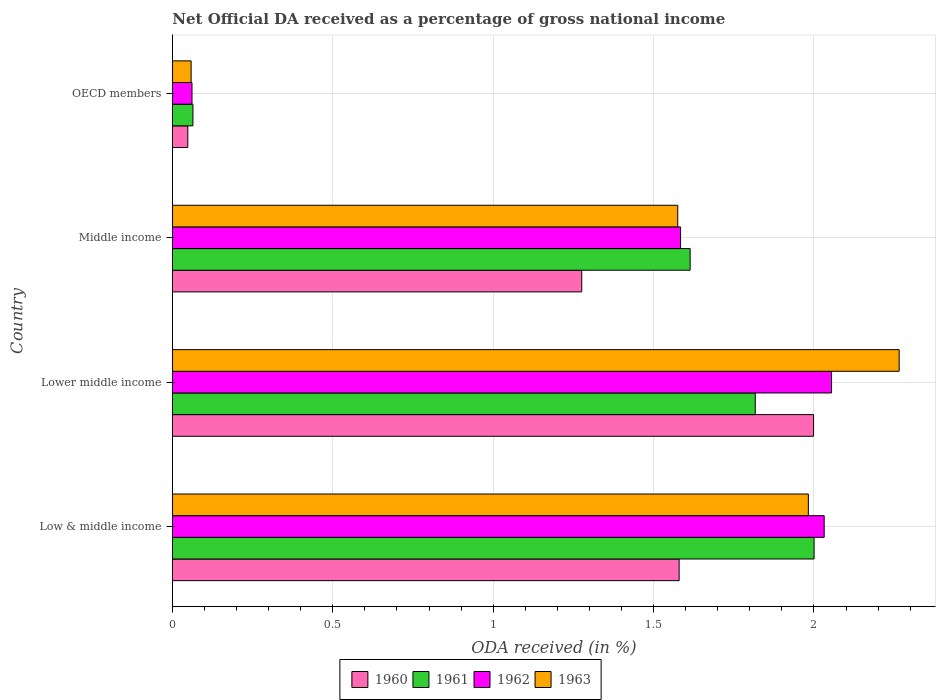How many different coloured bars are there?
Your answer should be very brief. 4. Are the number of bars per tick equal to the number of legend labels?
Provide a succinct answer. Yes. Are the number of bars on each tick of the Y-axis equal?
Offer a very short reply. Yes. How many bars are there on the 2nd tick from the bottom?
Your response must be concise. 4. What is the label of the 1st group of bars from the top?
Give a very brief answer. OECD members. In how many cases, is the number of bars for a given country not equal to the number of legend labels?
Ensure brevity in your answer.  0. What is the net official DA received in 1960 in Middle income?
Provide a succinct answer. 1.28. Across all countries, what is the maximum net official DA received in 1961?
Your answer should be compact. 2. Across all countries, what is the minimum net official DA received in 1961?
Offer a very short reply. 0.06. In which country was the net official DA received in 1961 maximum?
Provide a succinct answer. Low & middle income. What is the total net official DA received in 1960 in the graph?
Make the answer very short. 4.9. What is the difference between the net official DA received in 1962 in Low & middle income and that in Lower middle income?
Provide a short and direct response. -0.02. What is the difference between the net official DA received in 1963 in Middle income and the net official DA received in 1961 in Low & middle income?
Make the answer very short. -0.42. What is the average net official DA received in 1960 per country?
Your answer should be compact. 1.23. What is the difference between the net official DA received in 1960 and net official DA received in 1961 in Low & middle income?
Provide a succinct answer. -0.42. What is the ratio of the net official DA received in 1962 in Lower middle income to that in OECD members?
Provide a succinct answer. 33.57. What is the difference between the highest and the second highest net official DA received in 1961?
Your answer should be very brief. 0.18. What is the difference between the highest and the lowest net official DA received in 1963?
Ensure brevity in your answer.  2.21. Is it the case that in every country, the sum of the net official DA received in 1960 and net official DA received in 1961 is greater than the sum of net official DA received in 1963 and net official DA received in 1962?
Provide a succinct answer. No. What does the 2nd bar from the top in Lower middle income represents?
Offer a very short reply. 1962. What does the 4th bar from the bottom in Middle income represents?
Provide a short and direct response. 1963. Is it the case that in every country, the sum of the net official DA received in 1960 and net official DA received in 1963 is greater than the net official DA received in 1962?
Offer a terse response. Yes. How many countries are there in the graph?
Keep it short and to the point. 4. Does the graph contain any zero values?
Keep it short and to the point. No. Does the graph contain grids?
Your response must be concise. Yes. How are the legend labels stacked?
Offer a very short reply. Horizontal. What is the title of the graph?
Provide a short and direct response. Net Official DA received as a percentage of gross national income. What is the label or title of the X-axis?
Ensure brevity in your answer.  ODA received (in %). What is the label or title of the Y-axis?
Offer a terse response. Country. What is the ODA received (in %) in 1960 in Low & middle income?
Provide a short and direct response. 1.58. What is the ODA received (in %) in 1961 in Low & middle income?
Offer a terse response. 2. What is the ODA received (in %) of 1962 in Low & middle income?
Ensure brevity in your answer.  2.03. What is the ODA received (in %) in 1963 in Low & middle income?
Make the answer very short. 1.98. What is the ODA received (in %) of 1960 in Lower middle income?
Your answer should be very brief. 2. What is the ODA received (in %) in 1961 in Lower middle income?
Offer a terse response. 1.82. What is the ODA received (in %) in 1962 in Lower middle income?
Ensure brevity in your answer.  2.05. What is the ODA received (in %) in 1963 in Lower middle income?
Make the answer very short. 2.27. What is the ODA received (in %) of 1960 in Middle income?
Provide a short and direct response. 1.28. What is the ODA received (in %) in 1961 in Middle income?
Your answer should be compact. 1.61. What is the ODA received (in %) of 1962 in Middle income?
Offer a very short reply. 1.58. What is the ODA received (in %) of 1963 in Middle income?
Give a very brief answer. 1.58. What is the ODA received (in %) in 1960 in OECD members?
Provide a short and direct response. 0.05. What is the ODA received (in %) in 1961 in OECD members?
Offer a terse response. 0.06. What is the ODA received (in %) of 1962 in OECD members?
Offer a terse response. 0.06. What is the ODA received (in %) of 1963 in OECD members?
Your answer should be very brief. 0.06. Across all countries, what is the maximum ODA received (in %) of 1960?
Ensure brevity in your answer.  2. Across all countries, what is the maximum ODA received (in %) in 1961?
Offer a terse response. 2. Across all countries, what is the maximum ODA received (in %) in 1962?
Your answer should be very brief. 2.05. Across all countries, what is the maximum ODA received (in %) of 1963?
Provide a short and direct response. 2.27. Across all countries, what is the minimum ODA received (in %) in 1960?
Provide a succinct answer. 0.05. Across all countries, what is the minimum ODA received (in %) in 1961?
Offer a very short reply. 0.06. Across all countries, what is the minimum ODA received (in %) in 1962?
Your response must be concise. 0.06. Across all countries, what is the minimum ODA received (in %) of 1963?
Offer a very short reply. 0.06. What is the total ODA received (in %) of 1960 in the graph?
Ensure brevity in your answer.  4.9. What is the total ODA received (in %) of 1961 in the graph?
Your answer should be very brief. 5.5. What is the total ODA received (in %) in 1962 in the graph?
Your answer should be compact. 5.73. What is the total ODA received (in %) in 1963 in the graph?
Offer a terse response. 5.88. What is the difference between the ODA received (in %) of 1960 in Low & middle income and that in Lower middle income?
Provide a succinct answer. -0.42. What is the difference between the ODA received (in %) in 1961 in Low & middle income and that in Lower middle income?
Offer a very short reply. 0.18. What is the difference between the ODA received (in %) in 1962 in Low & middle income and that in Lower middle income?
Give a very brief answer. -0.02. What is the difference between the ODA received (in %) of 1963 in Low & middle income and that in Lower middle income?
Offer a terse response. -0.28. What is the difference between the ODA received (in %) of 1960 in Low & middle income and that in Middle income?
Your response must be concise. 0.3. What is the difference between the ODA received (in %) in 1961 in Low & middle income and that in Middle income?
Keep it short and to the point. 0.39. What is the difference between the ODA received (in %) in 1962 in Low & middle income and that in Middle income?
Provide a short and direct response. 0.45. What is the difference between the ODA received (in %) of 1963 in Low & middle income and that in Middle income?
Provide a succinct answer. 0.41. What is the difference between the ODA received (in %) in 1960 in Low & middle income and that in OECD members?
Your answer should be very brief. 1.53. What is the difference between the ODA received (in %) of 1961 in Low & middle income and that in OECD members?
Offer a terse response. 1.94. What is the difference between the ODA received (in %) of 1962 in Low & middle income and that in OECD members?
Offer a very short reply. 1.97. What is the difference between the ODA received (in %) of 1963 in Low & middle income and that in OECD members?
Offer a very short reply. 1.92. What is the difference between the ODA received (in %) of 1960 in Lower middle income and that in Middle income?
Make the answer very short. 0.72. What is the difference between the ODA received (in %) of 1961 in Lower middle income and that in Middle income?
Offer a very short reply. 0.2. What is the difference between the ODA received (in %) in 1962 in Lower middle income and that in Middle income?
Provide a succinct answer. 0.47. What is the difference between the ODA received (in %) of 1963 in Lower middle income and that in Middle income?
Make the answer very short. 0.69. What is the difference between the ODA received (in %) of 1960 in Lower middle income and that in OECD members?
Keep it short and to the point. 1.95. What is the difference between the ODA received (in %) of 1961 in Lower middle income and that in OECD members?
Keep it short and to the point. 1.75. What is the difference between the ODA received (in %) of 1962 in Lower middle income and that in OECD members?
Your response must be concise. 1.99. What is the difference between the ODA received (in %) of 1963 in Lower middle income and that in OECD members?
Give a very brief answer. 2.21. What is the difference between the ODA received (in %) of 1960 in Middle income and that in OECD members?
Your answer should be compact. 1.23. What is the difference between the ODA received (in %) in 1961 in Middle income and that in OECD members?
Provide a succinct answer. 1.55. What is the difference between the ODA received (in %) in 1962 in Middle income and that in OECD members?
Your answer should be compact. 1.52. What is the difference between the ODA received (in %) in 1963 in Middle income and that in OECD members?
Ensure brevity in your answer.  1.52. What is the difference between the ODA received (in %) of 1960 in Low & middle income and the ODA received (in %) of 1961 in Lower middle income?
Make the answer very short. -0.24. What is the difference between the ODA received (in %) of 1960 in Low & middle income and the ODA received (in %) of 1962 in Lower middle income?
Your response must be concise. -0.48. What is the difference between the ODA received (in %) of 1960 in Low & middle income and the ODA received (in %) of 1963 in Lower middle income?
Give a very brief answer. -0.69. What is the difference between the ODA received (in %) in 1961 in Low & middle income and the ODA received (in %) in 1962 in Lower middle income?
Offer a very short reply. -0.05. What is the difference between the ODA received (in %) in 1961 in Low & middle income and the ODA received (in %) in 1963 in Lower middle income?
Your answer should be compact. -0.27. What is the difference between the ODA received (in %) in 1962 in Low & middle income and the ODA received (in %) in 1963 in Lower middle income?
Your response must be concise. -0.23. What is the difference between the ODA received (in %) of 1960 in Low & middle income and the ODA received (in %) of 1961 in Middle income?
Make the answer very short. -0.03. What is the difference between the ODA received (in %) of 1960 in Low & middle income and the ODA received (in %) of 1962 in Middle income?
Provide a short and direct response. -0. What is the difference between the ODA received (in %) in 1960 in Low & middle income and the ODA received (in %) in 1963 in Middle income?
Your answer should be compact. 0. What is the difference between the ODA received (in %) of 1961 in Low & middle income and the ODA received (in %) of 1962 in Middle income?
Offer a very short reply. 0.42. What is the difference between the ODA received (in %) of 1961 in Low & middle income and the ODA received (in %) of 1963 in Middle income?
Give a very brief answer. 0.42. What is the difference between the ODA received (in %) in 1962 in Low & middle income and the ODA received (in %) in 1963 in Middle income?
Make the answer very short. 0.46. What is the difference between the ODA received (in %) of 1960 in Low & middle income and the ODA received (in %) of 1961 in OECD members?
Your response must be concise. 1.52. What is the difference between the ODA received (in %) in 1960 in Low & middle income and the ODA received (in %) in 1962 in OECD members?
Provide a succinct answer. 1.52. What is the difference between the ODA received (in %) in 1960 in Low & middle income and the ODA received (in %) in 1963 in OECD members?
Give a very brief answer. 1.52. What is the difference between the ODA received (in %) of 1961 in Low & middle income and the ODA received (in %) of 1962 in OECD members?
Your answer should be very brief. 1.94. What is the difference between the ODA received (in %) of 1961 in Low & middle income and the ODA received (in %) of 1963 in OECD members?
Keep it short and to the point. 1.94. What is the difference between the ODA received (in %) of 1962 in Low & middle income and the ODA received (in %) of 1963 in OECD members?
Your answer should be very brief. 1.97. What is the difference between the ODA received (in %) in 1960 in Lower middle income and the ODA received (in %) in 1961 in Middle income?
Keep it short and to the point. 0.38. What is the difference between the ODA received (in %) in 1960 in Lower middle income and the ODA received (in %) in 1962 in Middle income?
Your answer should be very brief. 0.41. What is the difference between the ODA received (in %) of 1960 in Lower middle income and the ODA received (in %) of 1963 in Middle income?
Your answer should be very brief. 0.42. What is the difference between the ODA received (in %) in 1961 in Lower middle income and the ODA received (in %) in 1962 in Middle income?
Make the answer very short. 0.23. What is the difference between the ODA received (in %) in 1961 in Lower middle income and the ODA received (in %) in 1963 in Middle income?
Offer a very short reply. 0.24. What is the difference between the ODA received (in %) of 1962 in Lower middle income and the ODA received (in %) of 1963 in Middle income?
Provide a short and direct response. 0.48. What is the difference between the ODA received (in %) of 1960 in Lower middle income and the ODA received (in %) of 1961 in OECD members?
Make the answer very short. 1.93. What is the difference between the ODA received (in %) of 1960 in Lower middle income and the ODA received (in %) of 1962 in OECD members?
Give a very brief answer. 1.94. What is the difference between the ODA received (in %) of 1960 in Lower middle income and the ODA received (in %) of 1963 in OECD members?
Provide a succinct answer. 1.94. What is the difference between the ODA received (in %) of 1961 in Lower middle income and the ODA received (in %) of 1962 in OECD members?
Offer a terse response. 1.76. What is the difference between the ODA received (in %) of 1961 in Lower middle income and the ODA received (in %) of 1963 in OECD members?
Provide a short and direct response. 1.76. What is the difference between the ODA received (in %) of 1962 in Lower middle income and the ODA received (in %) of 1963 in OECD members?
Your answer should be very brief. 2. What is the difference between the ODA received (in %) of 1960 in Middle income and the ODA received (in %) of 1961 in OECD members?
Keep it short and to the point. 1.21. What is the difference between the ODA received (in %) in 1960 in Middle income and the ODA received (in %) in 1962 in OECD members?
Keep it short and to the point. 1.21. What is the difference between the ODA received (in %) in 1960 in Middle income and the ODA received (in %) in 1963 in OECD members?
Keep it short and to the point. 1.22. What is the difference between the ODA received (in %) of 1961 in Middle income and the ODA received (in %) of 1962 in OECD members?
Provide a short and direct response. 1.55. What is the difference between the ODA received (in %) in 1961 in Middle income and the ODA received (in %) in 1963 in OECD members?
Provide a succinct answer. 1.56. What is the difference between the ODA received (in %) in 1962 in Middle income and the ODA received (in %) in 1963 in OECD members?
Provide a short and direct response. 1.53. What is the average ODA received (in %) in 1960 per country?
Offer a terse response. 1.23. What is the average ODA received (in %) of 1961 per country?
Give a very brief answer. 1.37. What is the average ODA received (in %) of 1962 per country?
Provide a succinct answer. 1.43. What is the average ODA received (in %) of 1963 per country?
Keep it short and to the point. 1.47. What is the difference between the ODA received (in %) in 1960 and ODA received (in %) in 1961 in Low & middle income?
Give a very brief answer. -0.42. What is the difference between the ODA received (in %) of 1960 and ODA received (in %) of 1962 in Low & middle income?
Keep it short and to the point. -0.45. What is the difference between the ODA received (in %) of 1960 and ODA received (in %) of 1963 in Low & middle income?
Make the answer very short. -0.4. What is the difference between the ODA received (in %) in 1961 and ODA received (in %) in 1962 in Low & middle income?
Provide a succinct answer. -0.03. What is the difference between the ODA received (in %) in 1961 and ODA received (in %) in 1963 in Low & middle income?
Offer a terse response. 0.02. What is the difference between the ODA received (in %) of 1962 and ODA received (in %) of 1963 in Low & middle income?
Ensure brevity in your answer.  0.05. What is the difference between the ODA received (in %) of 1960 and ODA received (in %) of 1961 in Lower middle income?
Your answer should be compact. 0.18. What is the difference between the ODA received (in %) of 1960 and ODA received (in %) of 1962 in Lower middle income?
Ensure brevity in your answer.  -0.06. What is the difference between the ODA received (in %) in 1960 and ODA received (in %) in 1963 in Lower middle income?
Provide a short and direct response. -0.27. What is the difference between the ODA received (in %) of 1961 and ODA received (in %) of 1962 in Lower middle income?
Ensure brevity in your answer.  -0.24. What is the difference between the ODA received (in %) in 1961 and ODA received (in %) in 1963 in Lower middle income?
Make the answer very short. -0.45. What is the difference between the ODA received (in %) of 1962 and ODA received (in %) of 1963 in Lower middle income?
Give a very brief answer. -0.21. What is the difference between the ODA received (in %) of 1960 and ODA received (in %) of 1961 in Middle income?
Give a very brief answer. -0.34. What is the difference between the ODA received (in %) of 1960 and ODA received (in %) of 1962 in Middle income?
Your answer should be very brief. -0.31. What is the difference between the ODA received (in %) of 1960 and ODA received (in %) of 1963 in Middle income?
Offer a very short reply. -0.3. What is the difference between the ODA received (in %) of 1961 and ODA received (in %) of 1962 in Middle income?
Offer a very short reply. 0.03. What is the difference between the ODA received (in %) in 1961 and ODA received (in %) in 1963 in Middle income?
Provide a succinct answer. 0.04. What is the difference between the ODA received (in %) in 1962 and ODA received (in %) in 1963 in Middle income?
Keep it short and to the point. 0.01. What is the difference between the ODA received (in %) of 1960 and ODA received (in %) of 1961 in OECD members?
Provide a short and direct response. -0.02. What is the difference between the ODA received (in %) of 1960 and ODA received (in %) of 1962 in OECD members?
Your answer should be compact. -0.01. What is the difference between the ODA received (in %) in 1960 and ODA received (in %) in 1963 in OECD members?
Offer a very short reply. -0.01. What is the difference between the ODA received (in %) in 1961 and ODA received (in %) in 1962 in OECD members?
Offer a very short reply. 0. What is the difference between the ODA received (in %) in 1961 and ODA received (in %) in 1963 in OECD members?
Ensure brevity in your answer.  0.01. What is the difference between the ODA received (in %) of 1962 and ODA received (in %) of 1963 in OECD members?
Offer a terse response. 0. What is the ratio of the ODA received (in %) in 1960 in Low & middle income to that in Lower middle income?
Your answer should be very brief. 0.79. What is the ratio of the ODA received (in %) of 1961 in Low & middle income to that in Lower middle income?
Provide a short and direct response. 1.1. What is the ratio of the ODA received (in %) of 1962 in Low & middle income to that in Lower middle income?
Your answer should be very brief. 0.99. What is the ratio of the ODA received (in %) in 1963 in Low & middle income to that in Lower middle income?
Provide a succinct answer. 0.88. What is the ratio of the ODA received (in %) of 1960 in Low & middle income to that in Middle income?
Provide a short and direct response. 1.24. What is the ratio of the ODA received (in %) of 1961 in Low & middle income to that in Middle income?
Your answer should be very brief. 1.24. What is the ratio of the ODA received (in %) in 1962 in Low & middle income to that in Middle income?
Your answer should be very brief. 1.28. What is the ratio of the ODA received (in %) of 1963 in Low & middle income to that in Middle income?
Make the answer very short. 1.26. What is the ratio of the ODA received (in %) of 1960 in Low & middle income to that in OECD members?
Offer a very short reply. 32.83. What is the ratio of the ODA received (in %) in 1961 in Low & middle income to that in OECD members?
Your answer should be very brief. 31.22. What is the ratio of the ODA received (in %) of 1962 in Low & middle income to that in OECD members?
Provide a succinct answer. 33.2. What is the ratio of the ODA received (in %) of 1963 in Low & middle income to that in OECD members?
Offer a terse response. 33.89. What is the ratio of the ODA received (in %) in 1960 in Lower middle income to that in Middle income?
Give a very brief answer. 1.57. What is the ratio of the ODA received (in %) in 1961 in Lower middle income to that in Middle income?
Your answer should be compact. 1.13. What is the ratio of the ODA received (in %) of 1962 in Lower middle income to that in Middle income?
Your response must be concise. 1.3. What is the ratio of the ODA received (in %) of 1963 in Lower middle income to that in Middle income?
Provide a succinct answer. 1.44. What is the ratio of the ODA received (in %) of 1960 in Lower middle income to that in OECD members?
Provide a succinct answer. 41.54. What is the ratio of the ODA received (in %) of 1961 in Lower middle income to that in OECD members?
Provide a short and direct response. 28.36. What is the ratio of the ODA received (in %) in 1962 in Lower middle income to that in OECD members?
Give a very brief answer. 33.57. What is the ratio of the ODA received (in %) in 1963 in Lower middle income to that in OECD members?
Ensure brevity in your answer.  38.73. What is the ratio of the ODA received (in %) in 1960 in Middle income to that in OECD members?
Make the answer very short. 26.52. What is the ratio of the ODA received (in %) in 1961 in Middle income to that in OECD members?
Offer a terse response. 25.19. What is the ratio of the ODA received (in %) of 1962 in Middle income to that in OECD members?
Your answer should be compact. 25.88. What is the ratio of the ODA received (in %) in 1963 in Middle income to that in OECD members?
Offer a very short reply. 26.93. What is the difference between the highest and the second highest ODA received (in %) of 1960?
Your answer should be very brief. 0.42. What is the difference between the highest and the second highest ODA received (in %) in 1961?
Ensure brevity in your answer.  0.18. What is the difference between the highest and the second highest ODA received (in %) of 1962?
Ensure brevity in your answer.  0.02. What is the difference between the highest and the second highest ODA received (in %) of 1963?
Offer a very short reply. 0.28. What is the difference between the highest and the lowest ODA received (in %) in 1960?
Keep it short and to the point. 1.95. What is the difference between the highest and the lowest ODA received (in %) of 1961?
Your answer should be compact. 1.94. What is the difference between the highest and the lowest ODA received (in %) of 1962?
Your response must be concise. 1.99. What is the difference between the highest and the lowest ODA received (in %) in 1963?
Keep it short and to the point. 2.21. 